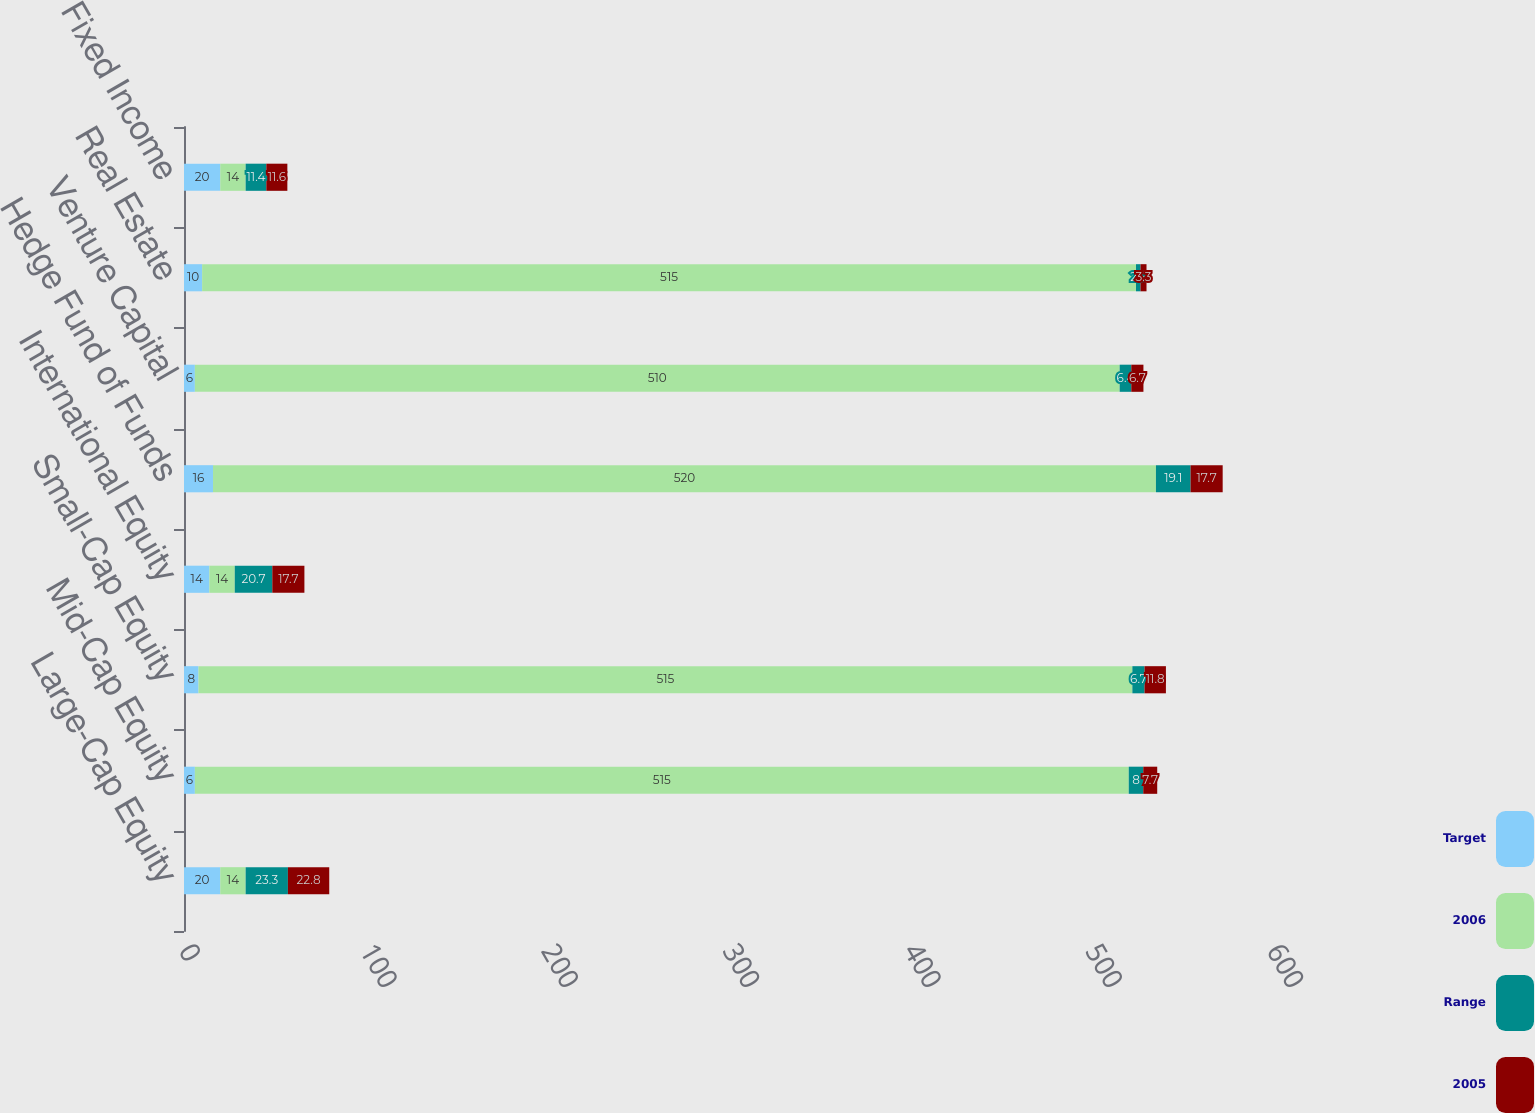Convert chart. <chart><loc_0><loc_0><loc_500><loc_500><stacked_bar_chart><ecel><fcel>Large-Cap Equity<fcel>Mid-Cap Equity<fcel>Small-Cap Equity<fcel>International Equity<fcel>Hedge Fund of Funds<fcel>Venture Capital<fcel>Real Estate<fcel>Fixed Income<nl><fcel>Target<fcel>20<fcel>6<fcel>8<fcel>14<fcel>16<fcel>6<fcel>10<fcel>20<nl><fcel>2006<fcel>14<fcel>515<fcel>515<fcel>14<fcel>520<fcel>510<fcel>515<fcel>14<nl><fcel>Range<fcel>23.3<fcel>8<fcel>6.7<fcel>20.7<fcel>19.1<fcel>6.4<fcel>2.5<fcel>11.4<nl><fcel>2005<fcel>22.8<fcel>7.7<fcel>11.8<fcel>17.7<fcel>17.7<fcel>6.7<fcel>3.3<fcel>11.6<nl></chart> 